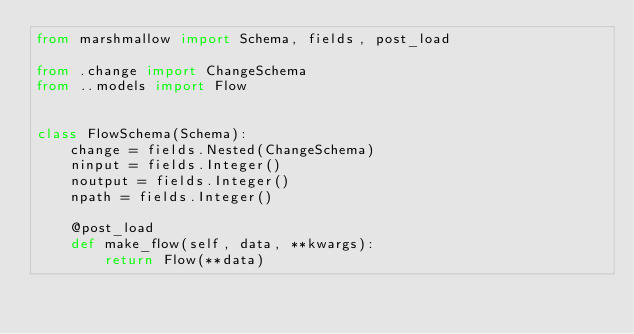<code> <loc_0><loc_0><loc_500><loc_500><_Python_>from marshmallow import Schema, fields, post_load

from .change import ChangeSchema
from ..models import Flow


class FlowSchema(Schema):
    change = fields.Nested(ChangeSchema)
    ninput = fields.Integer()
    noutput = fields.Integer()
    npath = fields.Integer()

    @post_load
    def make_flow(self, data, **kwargs):
        return Flow(**data)
</code> 